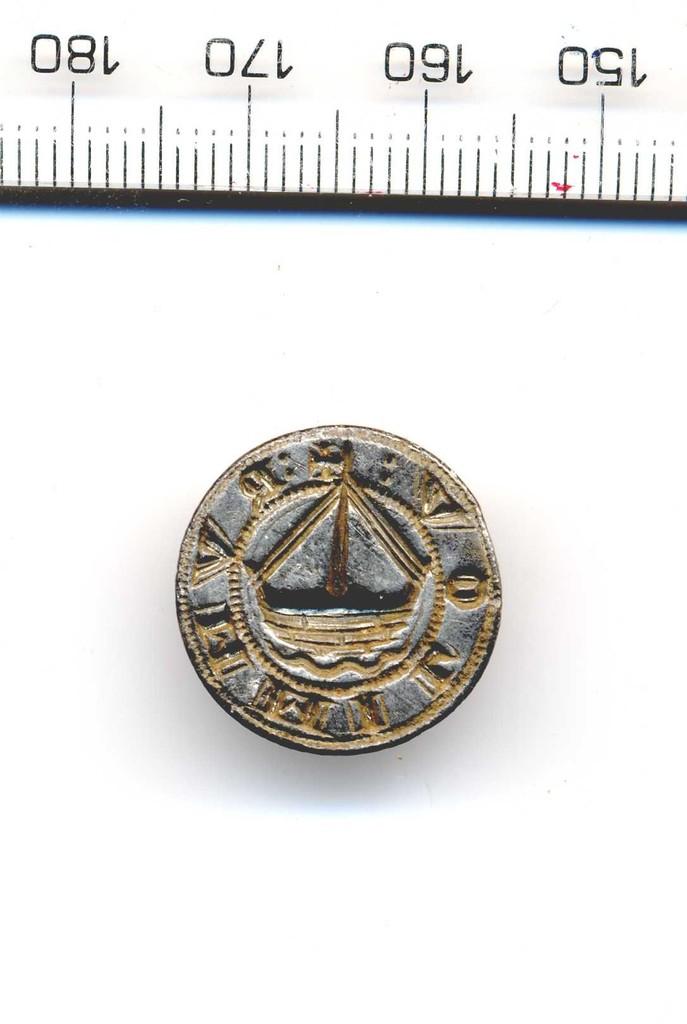What is the largest number listed on the ruler?
Your answer should be very brief. 180. 